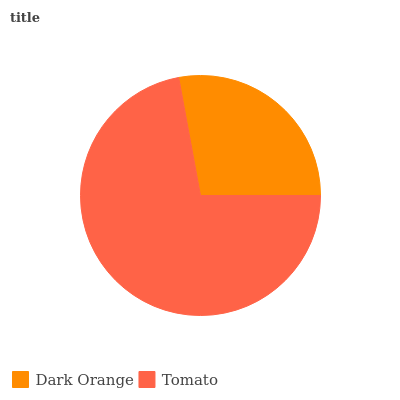Is Dark Orange the minimum?
Answer yes or no. Yes. Is Tomato the maximum?
Answer yes or no. Yes. Is Tomato the minimum?
Answer yes or no. No. Is Tomato greater than Dark Orange?
Answer yes or no. Yes. Is Dark Orange less than Tomato?
Answer yes or no. Yes. Is Dark Orange greater than Tomato?
Answer yes or no. No. Is Tomato less than Dark Orange?
Answer yes or no. No. Is Tomato the high median?
Answer yes or no. Yes. Is Dark Orange the low median?
Answer yes or no. Yes. Is Dark Orange the high median?
Answer yes or no. No. Is Tomato the low median?
Answer yes or no. No. 